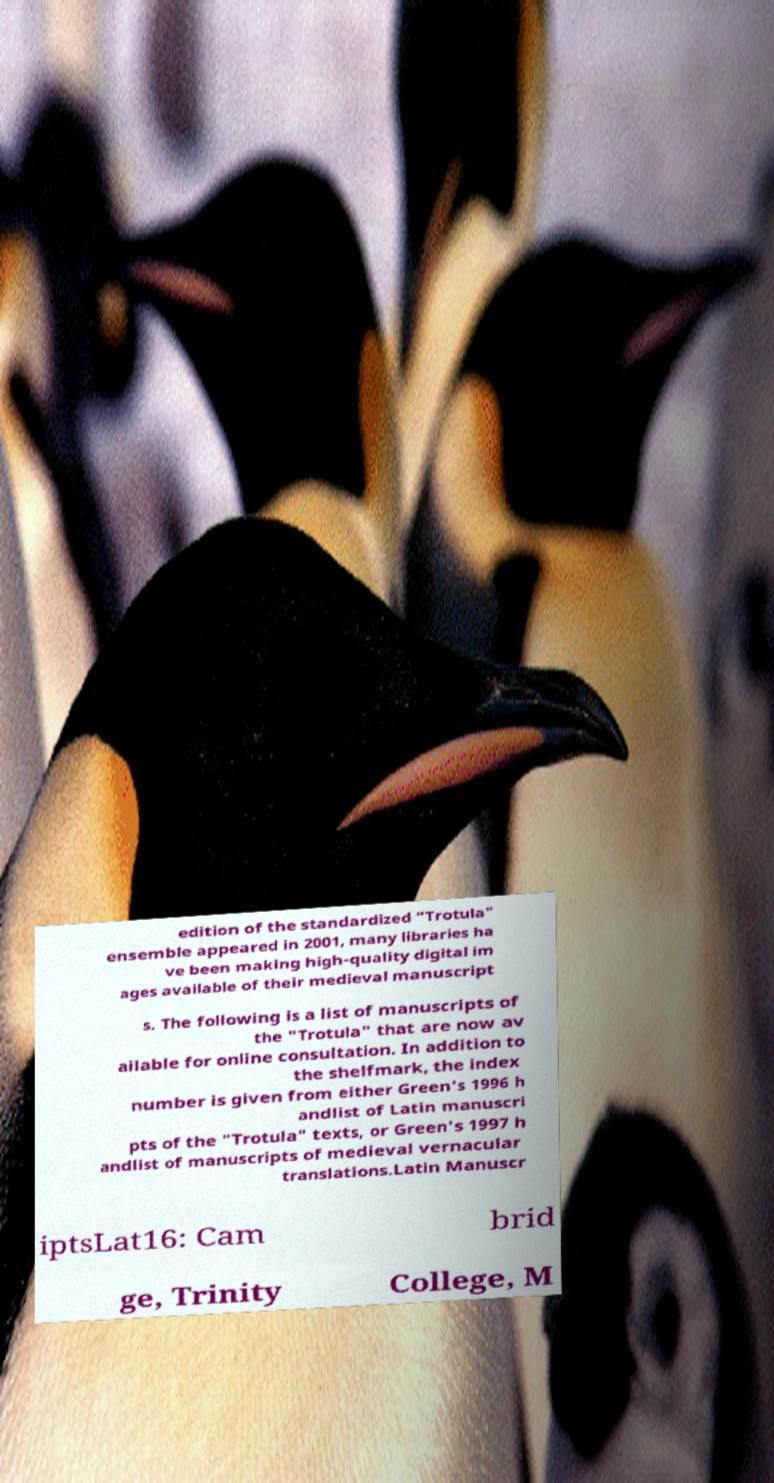Can you read and provide the text displayed in the image?This photo seems to have some interesting text. Can you extract and type it out for me? edition of the standardized "Trotula" ensemble appeared in 2001, many libraries ha ve been making high-quality digital im ages available of their medieval manuscript s. The following is a list of manuscripts of the "Trotula" that are now av ailable for online consultation. In addition to the shelfmark, the index number is given from either Green's 1996 h andlist of Latin manuscri pts of the "Trotula" texts, or Green's 1997 h andlist of manuscripts of medieval vernacular translations.Latin Manuscr iptsLat16: Cam brid ge, Trinity College, M 